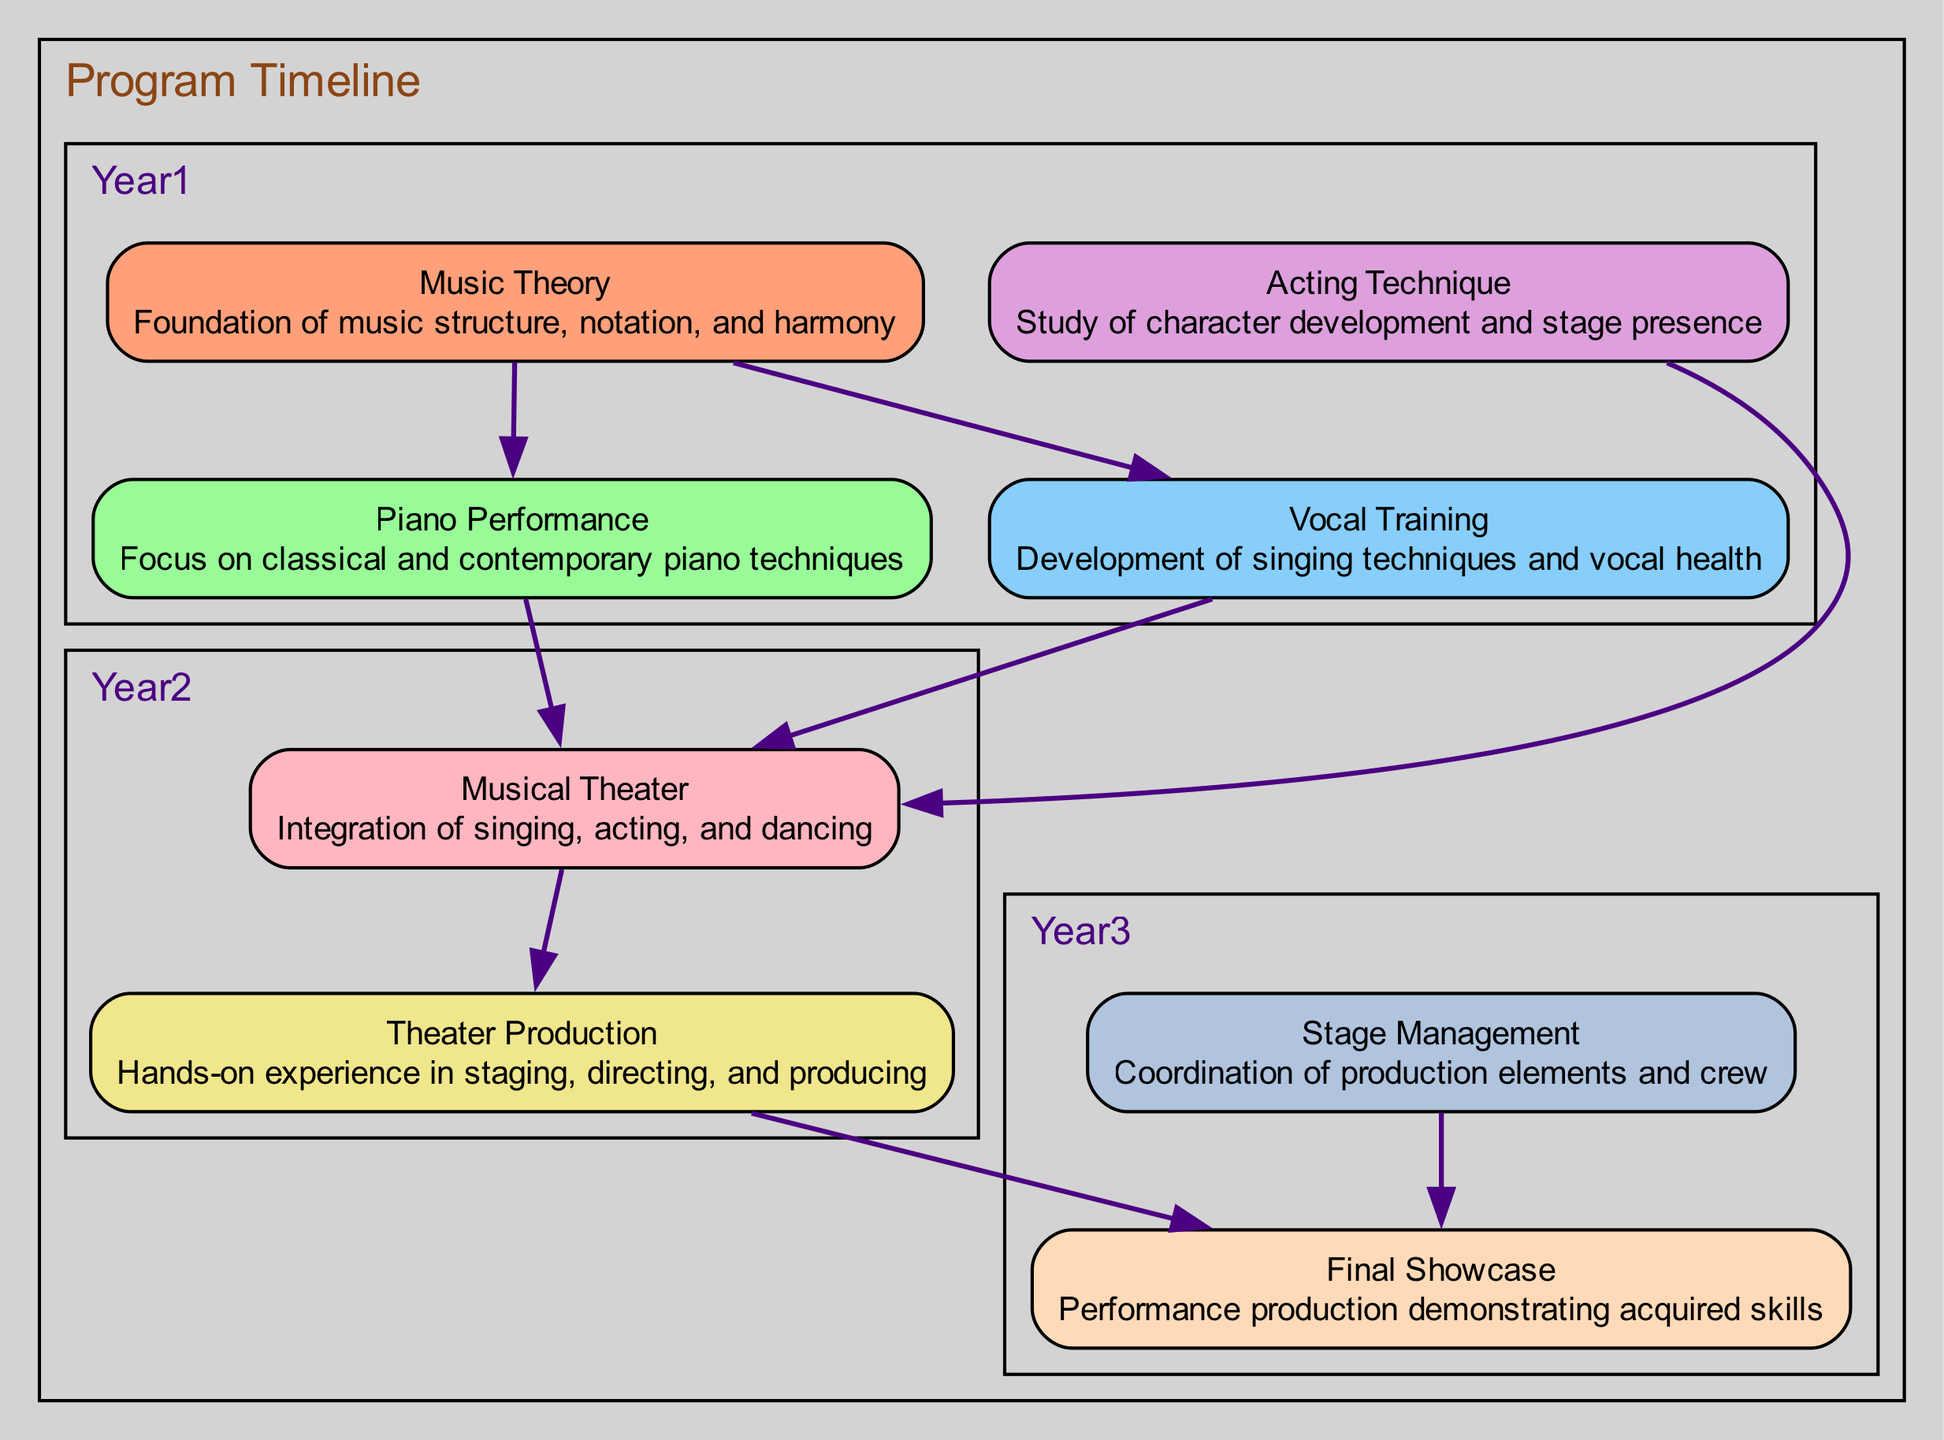What is the first course in the timeline? The timeline starts with the first year, which lists the courses "Music Theory," "Piano Performance," "Vocal Training," and "Acting Technique." The first course mentioned is "Music Theory."
Answer: Music Theory How many total nodes are there in the diagram? The diagram contains eight nodes: Music Theory, Piano Performance, Vocal Training, Acting Technique, Theater Production, Musical Theater, Stage Management, and Final Showcase. Therefore, the total number of nodes is eight.
Answer: Eight Which courses lead to Musical Theater? There are three courses that lead to "Musical Theater": "Piano Performance," "Vocal Training," and "Acting Technique." Each of these courses connects directly to Musical Theater in the directed graph.
Answer: Piano Performance, Vocal Training, Acting Technique What course follows Theater Production? According to the diagram, "Theater Production" has a direct edge leading to "Final Showcase," meaning that "Final Showcase" follows "Theater Production."
Answer: Final Showcase How many edges are there in total? To determine the total number of edges, we can count them in the diagram. There are a total of seven edges between the nodes, showing the relationships and paths between different courses.
Answer: Seven Which course is described as the study of character development? The course that focuses on the study of character development is labeled "Acting Technique," as indicated in its description within the diagram.
Answer: Acting Technique Which two courses are prerequisites for the Final Showcase? The two courses that have direct edges leading to "Final Showcase" are "Theater Production" and "Stage Management." Therefore, these two courses are prerequisites for it.
Answer: Theater Production, Stage Management In which year does Musical Theater occur? Musical Theater is listed in the second year of the timeline along with "Theater Production." Thus, it occurs during the second year.
Answer: Year Two 